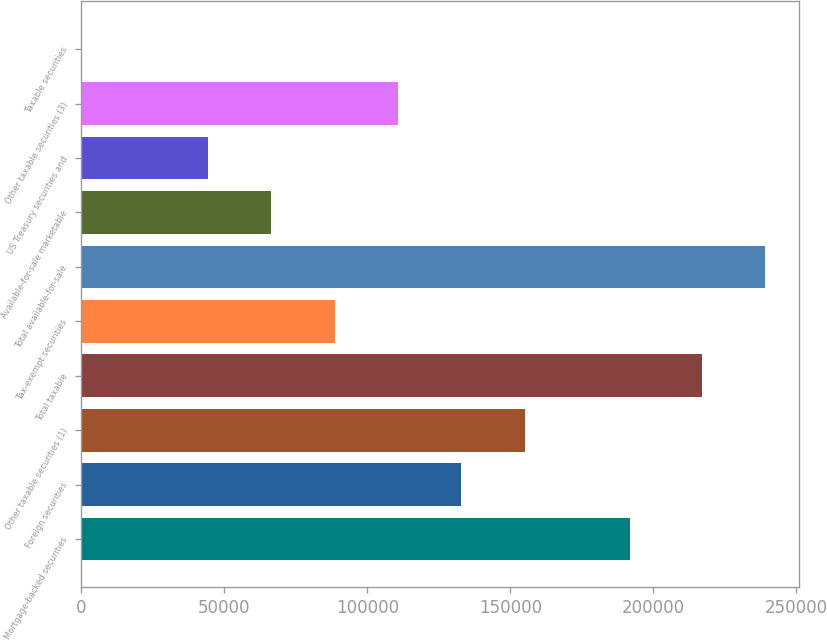Convert chart to OTSL. <chart><loc_0><loc_0><loc_500><loc_500><bar_chart><fcel>Mortgage-backed securities<fcel>Foreign securities<fcel>Other taxable securities (1)<fcel>Total taxable<fcel>Tax-exempt securities<fcel>Total available-for-sale<fcel>Available-for-sale marketable<fcel>US Treasury securities and<fcel>Other taxable securities (3)<fcel>Taxable securities<nl><fcel>192031<fcel>132950<fcel>155102<fcel>216864<fcel>88647<fcel>239016<fcel>66495.5<fcel>44344<fcel>110798<fcel>41<nl></chart> 